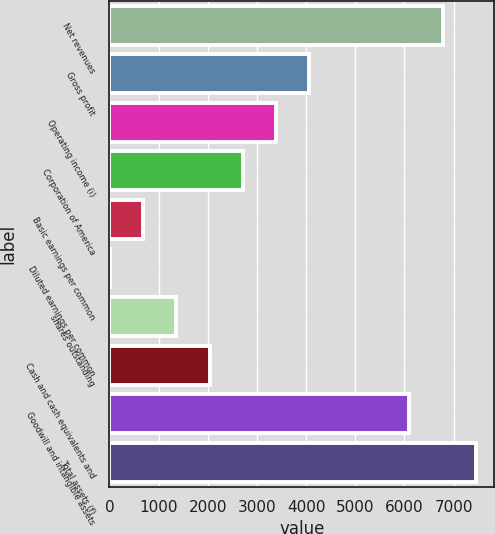Convert chart to OTSL. <chart><loc_0><loc_0><loc_500><loc_500><bar_chart><fcel>Net revenues<fcel>Gross profit<fcel>Operating income (i)<fcel>Corporation of America<fcel>Basic earnings per common<fcel>Diluted earnings per common<fcel>shares outstanding<fcel>Cash and cash equivalents and<fcel>Goodwill and intangible assets<fcel>Total assets (f)<nl><fcel>6774.39<fcel>4067.03<fcel>3390.19<fcel>2713.35<fcel>682.83<fcel>5.99<fcel>1359.67<fcel>2036.51<fcel>6097.55<fcel>7451.23<nl></chart> 